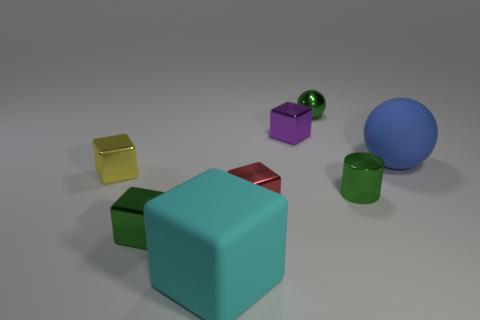Subtract all small red shiny cubes. How many cubes are left? 4 Subtract all yellow blocks. How many blocks are left? 4 Subtract all blue cubes. Subtract all yellow balls. How many cubes are left? 5 Add 1 small yellow shiny things. How many objects exist? 9 Subtract all cylinders. How many objects are left? 7 Subtract all small yellow shiny things. Subtract all red blocks. How many objects are left? 6 Add 3 small shiny cylinders. How many small shiny cylinders are left? 4 Add 5 large shiny blocks. How many large shiny blocks exist? 5 Subtract 1 cyan cubes. How many objects are left? 7 